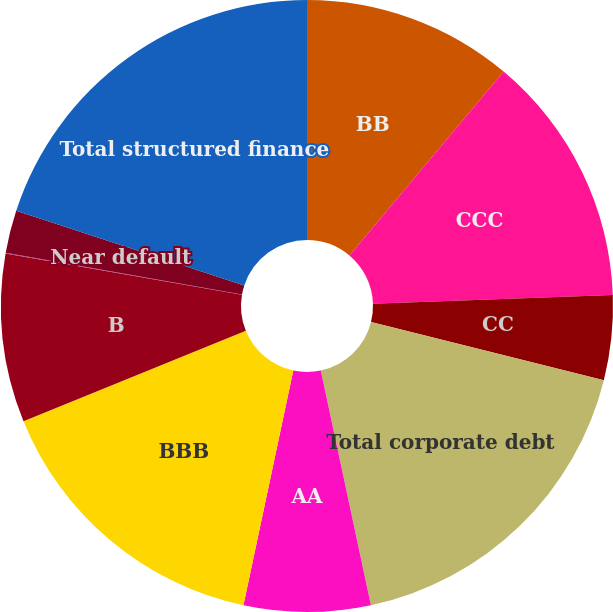Convert chart to OTSL. <chart><loc_0><loc_0><loc_500><loc_500><pie_chart><fcel>BB<fcel>CCC<fcel>CC<fcel>Total corporate debt<fcel>AA<fcel>BBB<fcel>B<fcel>C<fcel>Near default<fcel>Total structured finance<nl><fcel>11.11%<fcel>13.32%<fcel>4.47%<fcel>17.75%<fcel>6.68%<fcel>15.53%<fcel>8.89%<fcel>0.04%<fcel>2.25%<fcel>19.96%<nl></chart> 